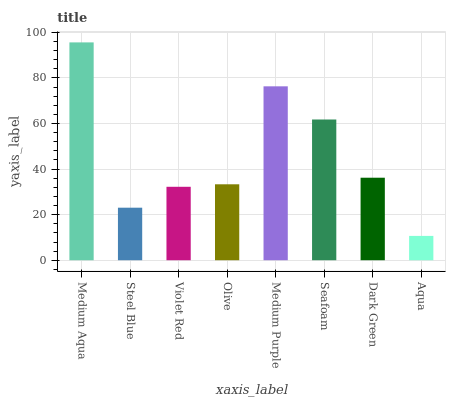Is Aqua the minimum?
Answer yes or no. Yes. Is Medium Aqua the maximum?
Answer yes or no. Yes. Is Steel Blue the minimum?
Answer yes or no. No. Is Steel Blue the maximum?
Answer yes or no. No. Is Medium Aqua greater than Steel Blue?
Answer yes or no. Yes. Is Steel Blue less than Medium Aqua?
Answer yes or no. Yes. Is Steel Blue greater than Medium Aqua?
Answer yes or no. No. Is Medium Aqua less than Steel Blue?
Answer yes or no. No. Is Dark Green the high median?
Answer yes or no. Yes. Is Olive the low median?
Answer yes or no. Yes. Is Violet Red the high median?
Answer yes or no. No. Is Medium Aqua the low median?
Answer yes or no. No. 